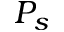Convert formula to latex. <formula><loc_0><loc_0><loc_500><loc_500>P _ { s }</formula> 